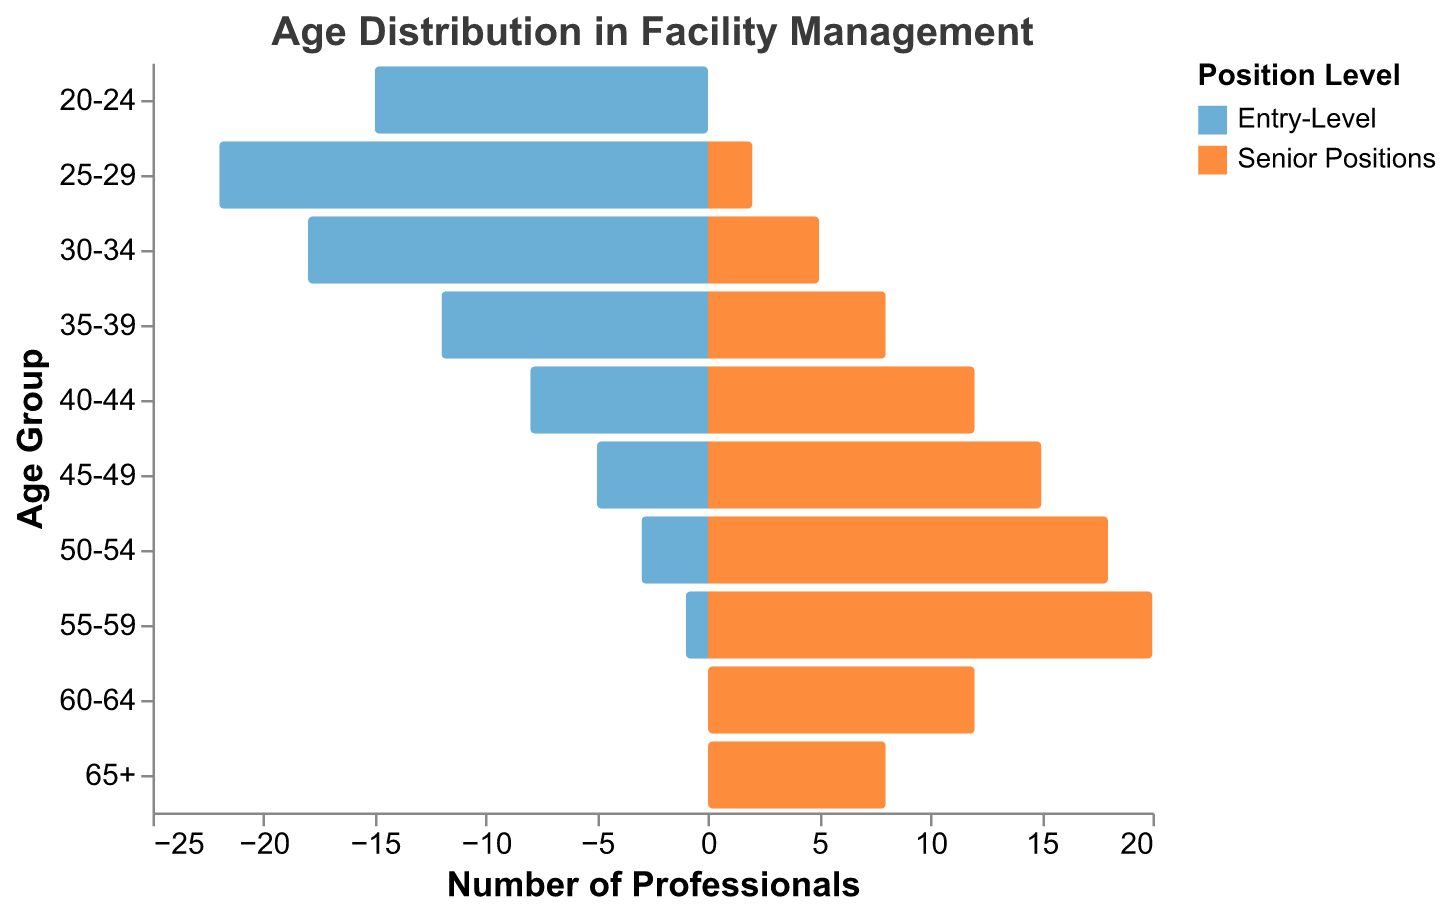What is the title of the figure? The title is located at the top of the figure and reads: "Age Distribution in Facility Management".
Answer: Age Distribution in Facility Management What age group has the highest number of entry-level professionals? Look at the bars representing entry-level professionals and find the tallest bar. The tallest bar for entry-level professionals is the one for the age group 25-29.
Answer: 25-29 How many senior professionals are in the age group 50-54? Refer to the bar corresponding to senior positions for the age group 50-54. The height of the bar shows the number of professionals, which is 18.
Answer: 18 Compare the number of entry-level and senior professionals in the age group 40-44. Which one is higher and by how much? Identify the two bars for the age group 40-44. Entry-level has 8, and senior positions have 12. Calculate the difference: 12 - 8 = 4. Senior professionals are higher by 4.
Answer: Senior professionals by 4 Which age group shows no entry-level professionals? Look for the age group bars where the count for entry-level professionals is zero. The age groups 60-64 and 65+ both have no entry-level professionals.
Answer: 60-64, 65+ What is the total number of entry-level professionals in the age range 35-44? Add the number of entry-level professionals in the age groups 35-39 and 40-44. This is 12 (35-39) + 8 (40-44) = 20.
Answer: 20 How does the number of senior professionals in the age group 55-59 compare to the same group in entry-level positions? Check the numbers for both senior and entry-level professionals in the age group 55-59. Entry-level has 1, and senior positions have 20. Senior professionals outnumber entry-level by 19.
Answer: Senior professionals by 19 Which age group has an equal number of entry-level and senior professionals? Find age groups where the two bars are of equal length. The age group 20-24 has 15 entry-level professionals and 0 senior professionals, which does not match. No age group has equal numbers in both categories.
Answer: None How many more senior professionals are there over the age of 50 compared to entry-level? Add the numbers for the age groups 50-54, 55-59, 60-64, and 65+ for both categories. Entry-level: 3 + 1 + 0 + 0 = 4. Senior positions: 18 + 20 + 12 + 8 = 58. The difference is 58 - 4 = 54.
Answer: 54 